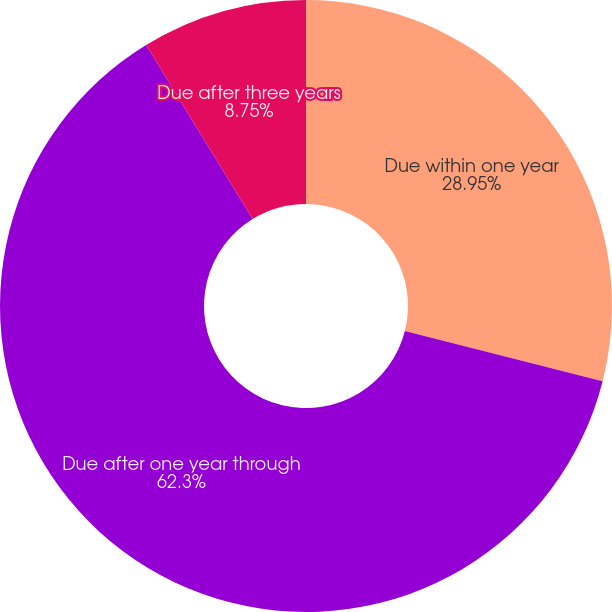Convert chart to OTSL. <chart><loc_0><loc_0><loc_500><loc_500><pie_chart><fcel>Due within one year<fcel>Due after one year through<fcel>Due after three years<nl><fcel>28.95%<fcel>62.3%<fcel>8.75%<nl></chart> 